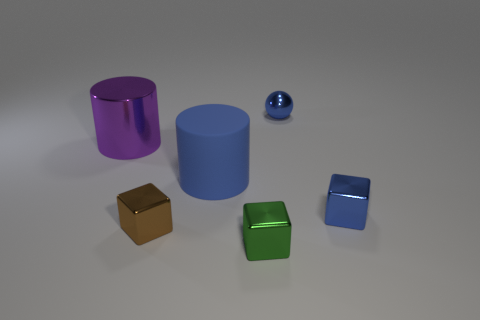What size is the thing on the left side of the small brown cube?
Offer a very short reply. Large. There is a large thing that is the same color as the tiny ball; what shape is it?
Your answer should be very brief. Cylinder. Does the large purple object have the same material as the small blue object in front of the metallic sphere?
Provide a succinct answer. Yes. There is a tiny blue metallic thing to the left of the blue shiny thing that is in front of the sphere; what number of tiny blue shiny objects are in front of it?
Your answer should be compact. 1. How many yellow things are either tiny cubes or tiny shiny spheres?
Your answer should be compact. 0. There is a small blue metal object in front of the large rubber cylinder; what shape is it?
Offer a very short reply. Cube. What color is the ball that is the same size as the blue cube?
Make the answer very short. Blue. There is a blue matte object; does it have the same shape as the metallic object that is behind the large purple thing?
Provide a succinct answer. No. What is the material of the large cylinder that is to the right of the big cylinder on the left side of the large object that is to the right of the purple metallic cylinder?
Ensure brevity in your answer.  Rubber. How many big things are either blocks or blue rubber cylinders?
Your answer should be compact. 1. 